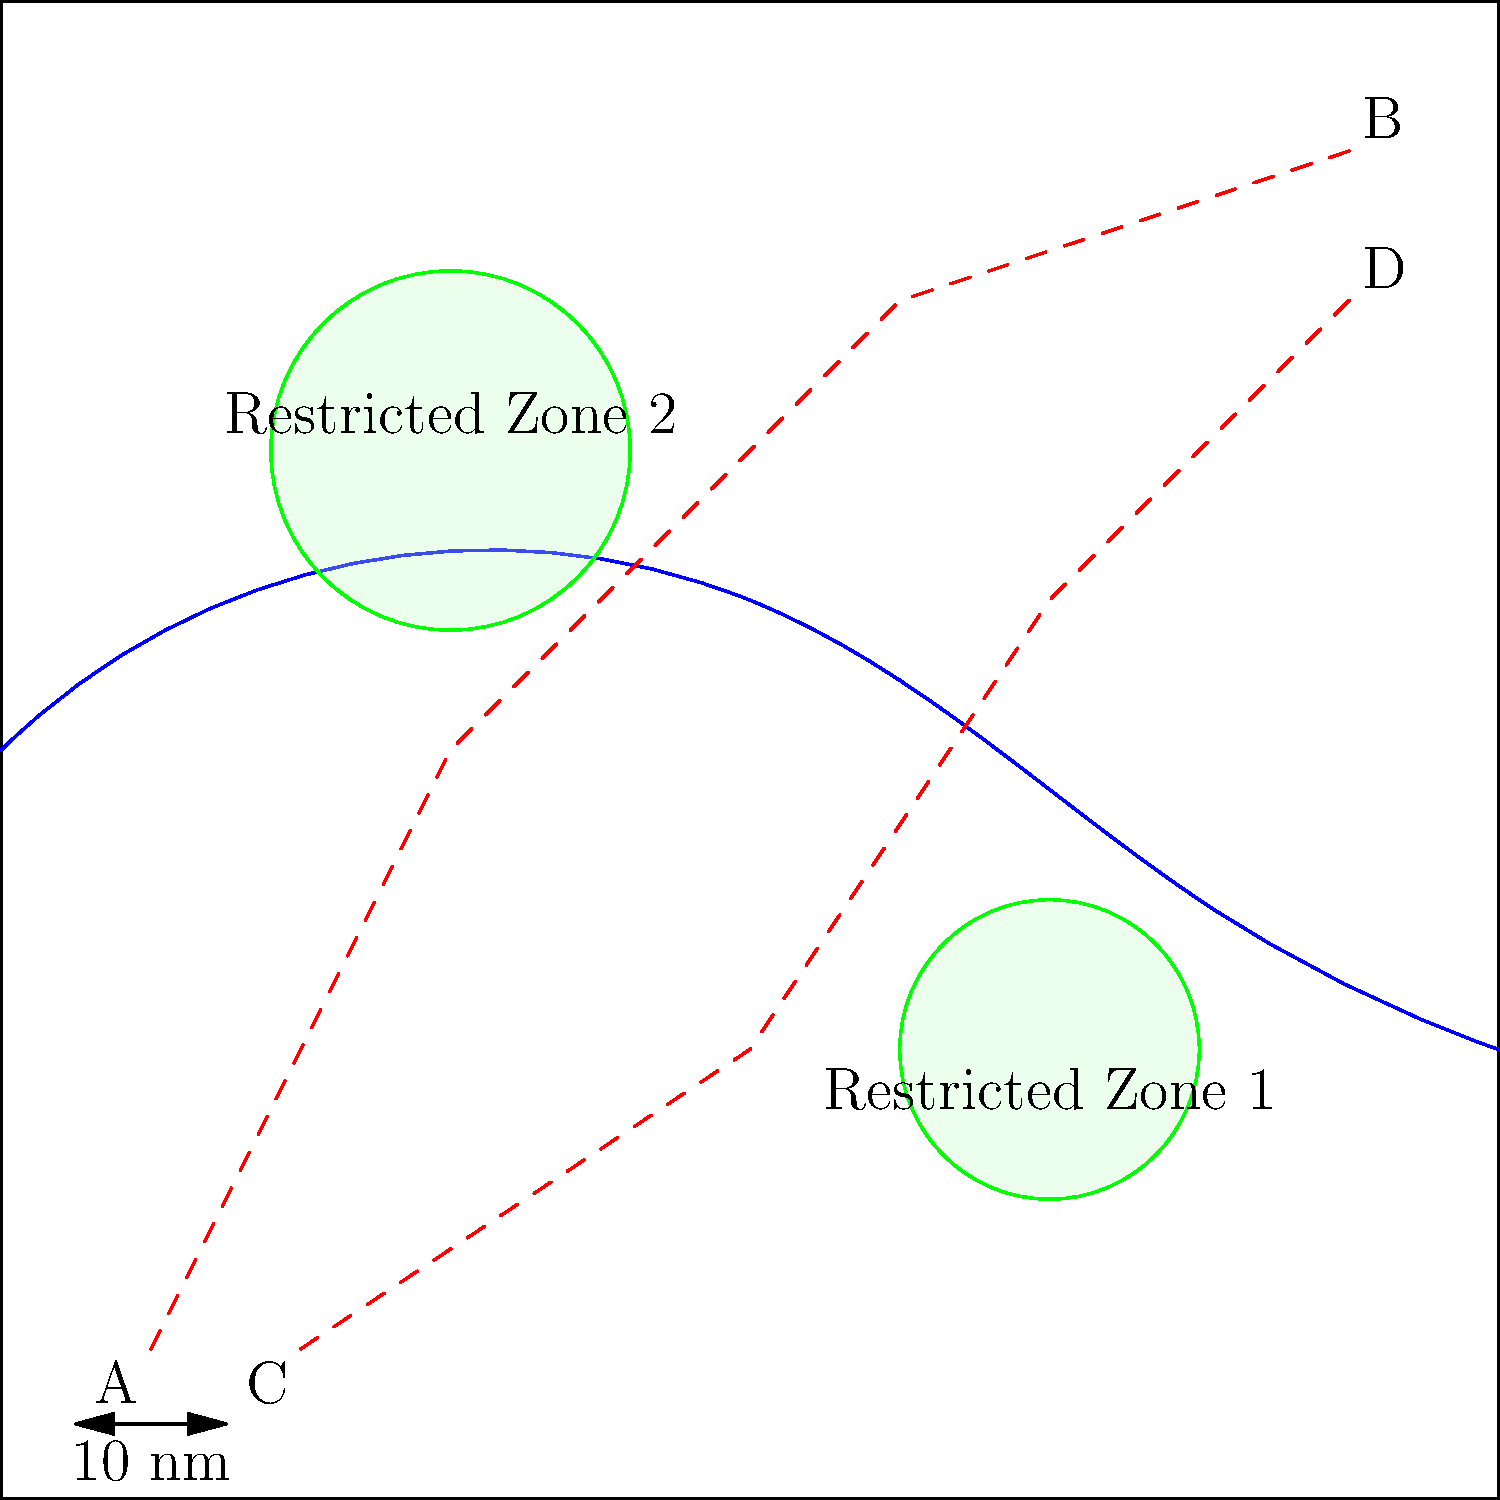Given the nautical chart showing fishing vessel routes and restricted zones, which route poses the least risk of violating shark protection regulations? To determine which route poses the least risk of violating shark protection regulations, we need to analyze both routes in relation to the restricted zones:

1. Identify the routes:
   - Route A-B: From point A (-4,-4) to point B (4,4)
   - Route C-D: From point C (-3,-4) to point D (4,3)

2. Analyze Route A-B:
   - This route passes through Restricted Zone 2 near (-2,2)
   - Entering a restricted zone is likely to violate shark protection regulations

3. Analyze Route C-D:
   - This route passes between the two restricted zones
   - It doesn't enter either of the restricted areas

4. Compare the routes:
   - Route A-B violates a restricted zone
   - Route C-D avoids both restricted zones

5. Consider the implications:
   - Entering restricted zones may harm shark populations or violate fishing regulations
   - Avoiding restricted zones helps protect shark habitats and comply with regulations

Therefore, Route C-D poses the least risk of violating shark protection regulations as it avoids both restricted zones.
Answer: Route C-D 